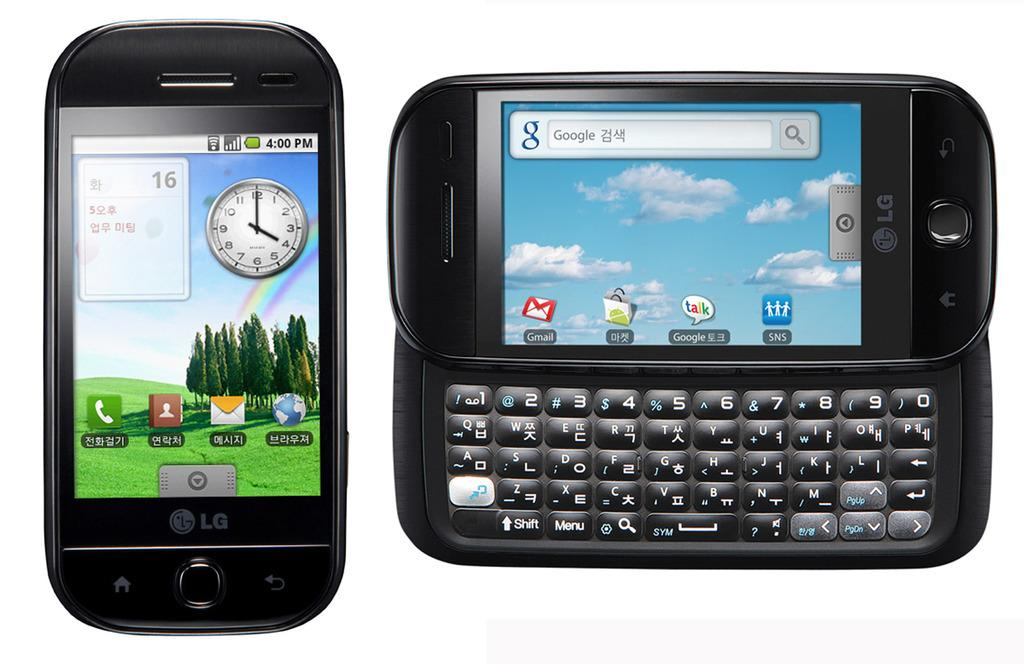<image>
Relay a brief, clear account of the picture shown. An LG cellphone has a sliding screen with a full keyboard under it. 